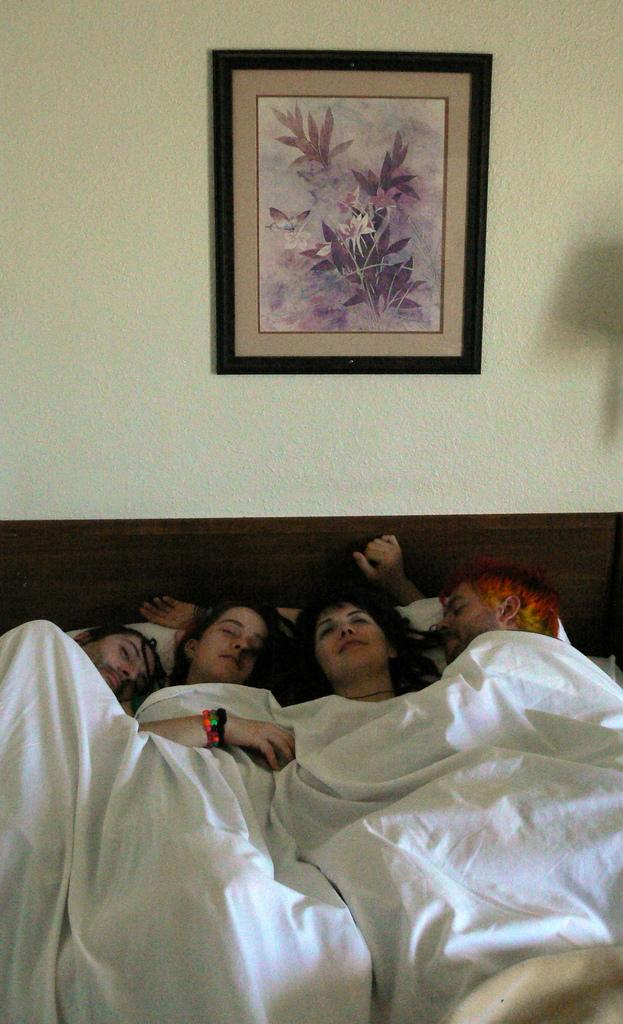How many people are lying on the bed in the image? There are four people lying on the bed in the image. What are the people covered with while lying on the bed? The people have bed sheets on them. What can be seen on the wall in the background of the image? There is a wall with a frame in the background, and there is a painting in the frame on the wall. What advice does the painting in the frame on the wall give to the people lying on the bed? The painting in the frame on the wall does not give any advice to the people lying on the bed, as it is an inanimate object and cannot communicate. 